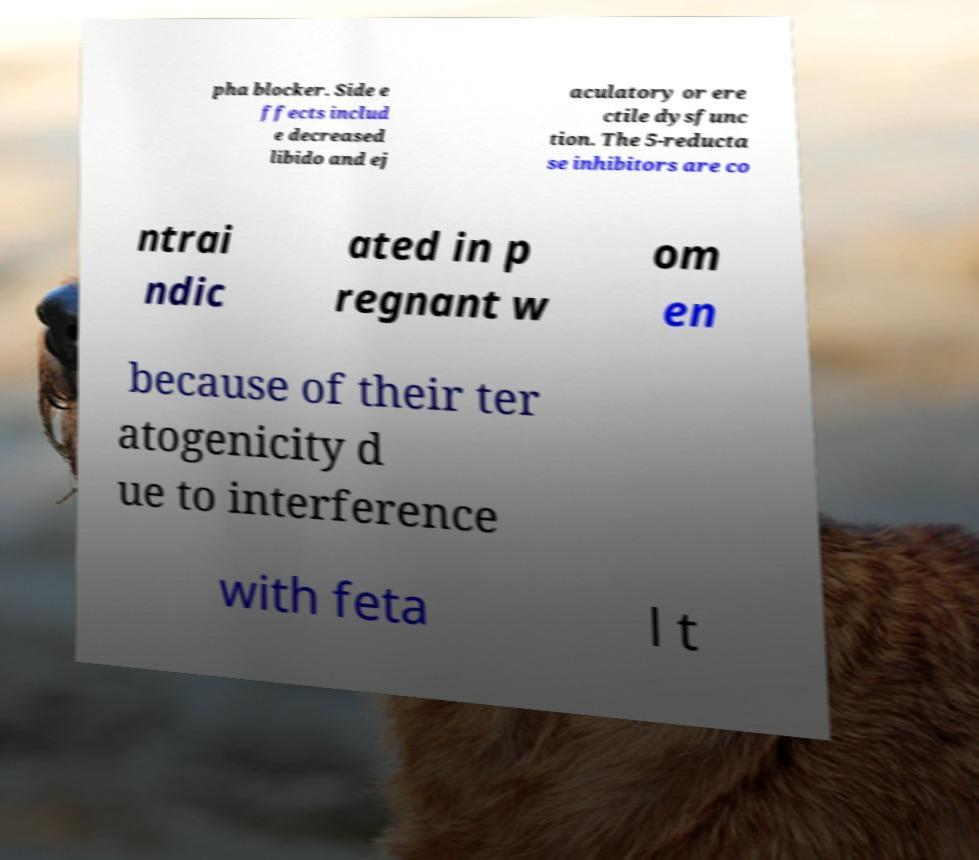Could you assist in decoding the text presented in this image and type it out clearly? pha blocker. Side e ffects includ e decreased libido and ej aculatory or ere ctile dysfunc tion. The 5-reducta se inhibitors are co ntrai ndic ated in p regnant w om en because of their ter atogenicity d ue to interference with feta l t 